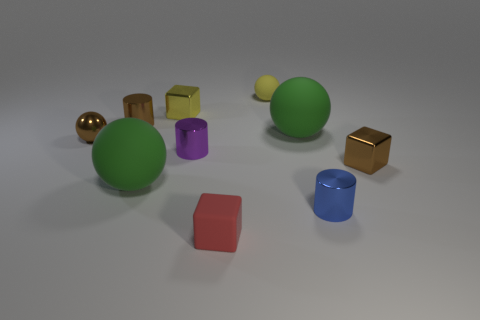Is the number of green matte balls that are on the left side of the tiny red object the same as the number of yellow rubber cubes?
Provide a succinct answer. No. What is the thing in front of the small shiny cylinder that is in front of the purple shiny object that is right of the brown shiny cylinder made of?
Offer a very short reply. Rubber. There is a tiny metallic block that is behind the brown cylinder; what color is it?
Make the answer very short. Yellow. Are there any other things that have the same shape as the small yellow rubber thing?
Your response must be concise. Yes. How big is the blue shiny cylinder right of the big ball that is to the right of the small matte cube?
Your response must be concise. Small. Are there an equal number of tiny brown cylinders that are right of the red thing and rubber spheres to the left of the tiny rubber sphere?
Make the answer very short. No. Are there any other things that have the same size as the blue metal object?
Provide a succinct answer. Yes. The small ball that is the same material as the small purple object is what color?
Make the answer very short. Brown. Are the tiny red cube and the small yellow object on the left side of the tiny yellow rubber sphere made of the same material?
Your response must be concise. No. What color is the object that is both to the right of the yellow matte ball and to the left of the blue cylinder?
Provide a succinct answer. Green. 